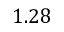<formula> <loc_0><loc_0><loc_500><loc_500>1 . 2 8</formula> 